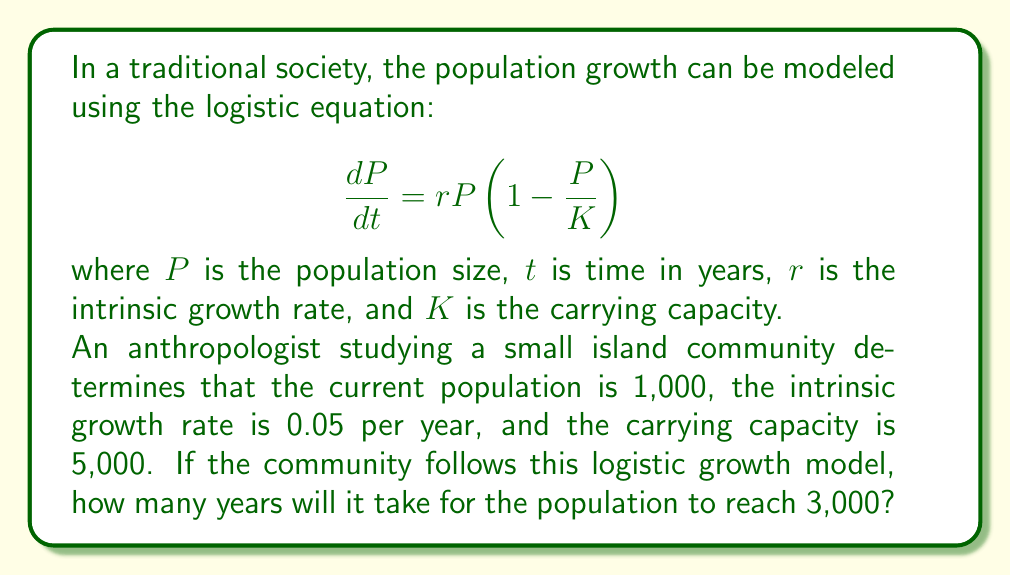Solve this math problem. To solve this problem, we need to use the integrated form of the logistic equation:

$$P(t) = \frac{K}{1 + (\frac{K}{P_0} - 1)e^{-rt}}$$

Where:
$P(t)$ is the population at time $t$
$K$ is the carrying capacity (5,000)
$P_0$ is the initial population (1,000)
$r$ is the intrinsic growth rate (0.05)

We want to find $t$ when $P(t) = 3,000$. Let's substitute these values into the equation:

$$3000 = \frac{5000}{1 + (\frac{5000}{1000} - 1)e^{-0.05t}}$$

Now, let's solve for $t$:

1) Simplify the right side:
   $$3000 = \frac{5000}{1 + 4e^{-0.05t}}$$

2) Multiply both sides by $(1 + 4e^{-0.05t})$:
   $$3000(1 + 4e^{-0.05t}) = 5000$$

3) Expand:
   $$3000 + 12000e^{-0.05t} = 5000$$

4) Subtract 3000 from both sides:
   $$12000e^{-0.05t} = 2000$$

5) Divide both sides by 12000:
   $$e^{-0.05t} = \frac{1}{6}$$

6) Take the natural log of both sides:
   $$-0.05t = \ln(\frac{1}{6})$$

7) Divide both sides by -0.05:
   $$t = -\frac{\ln(\frac{1}{6})}{0.05}$$

8) Simplify:
   $$t = \frac{\ln(6)}{0.05} \approx 35.84$$

Therefore, it will take approximately 35.84 years for the population to reach 3,000.
Answer: Approximately 35.84 years 